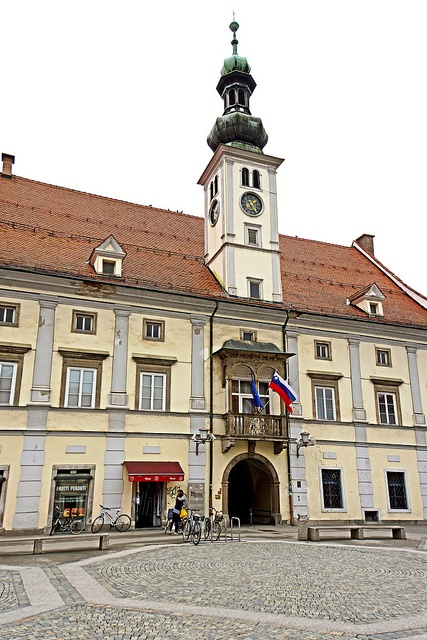Describe the objects in this image and their specific colors. I can see bench in white, gray, and darkgray tones, bench in white, gray, black, and darkgray tones, bicycle in white, black, gray, and darkgray tones, bicycle in white, black, darkgray, gray, and tan tones, and bicycle in white, black, gray, darkgray, and tan tones in this image. 